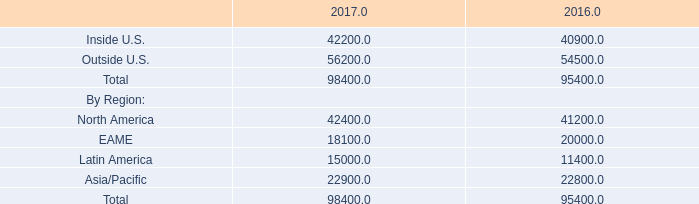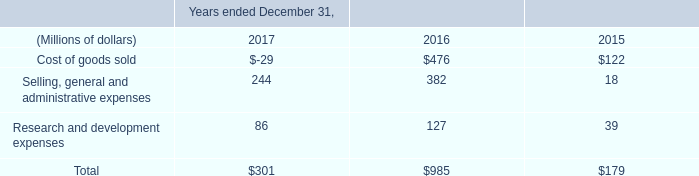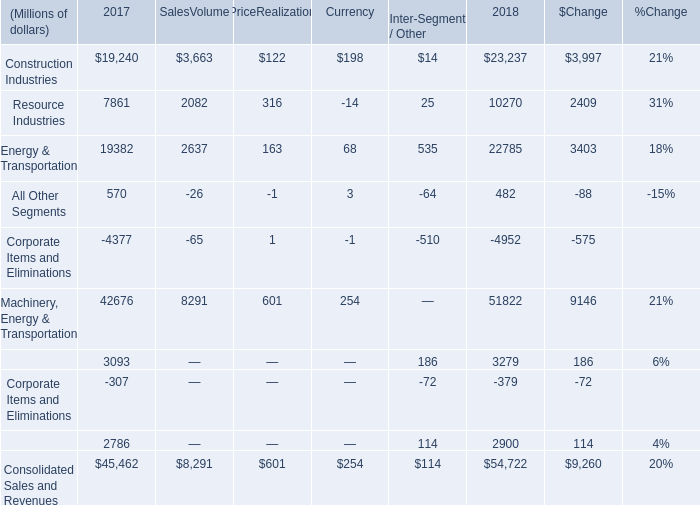What is the proportion of all Machinery, Energy & Transportation that are greater than 600 to the total amount in 2018? 
Computations: (((42676 + 8291) + 601) / (((42676 + 8291) + 601) + 254))
Answer: 0.9951. 